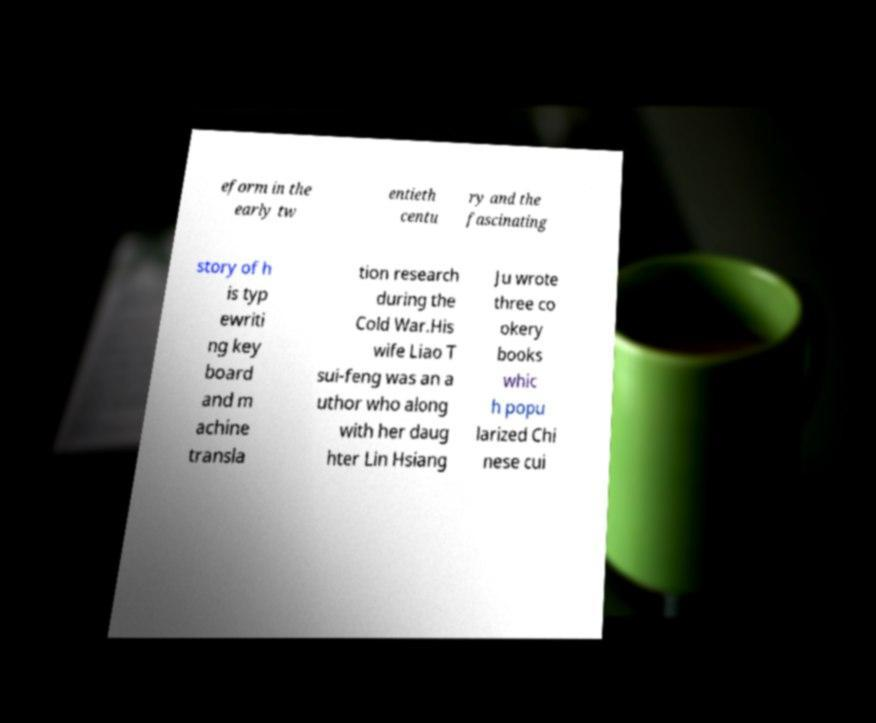I need the written content from this picture converted into text. Can you do that? eform in the early tw entieth centu ry and the fascinating story of h is typ ewriti ng key board and m achine transla tion research during the Cold War.His wife Liao T sui-feng was an a uthor who along with her daug hter Lin Hsiang Ju wrote three co okery books whic h popu larized Chi nese cui 